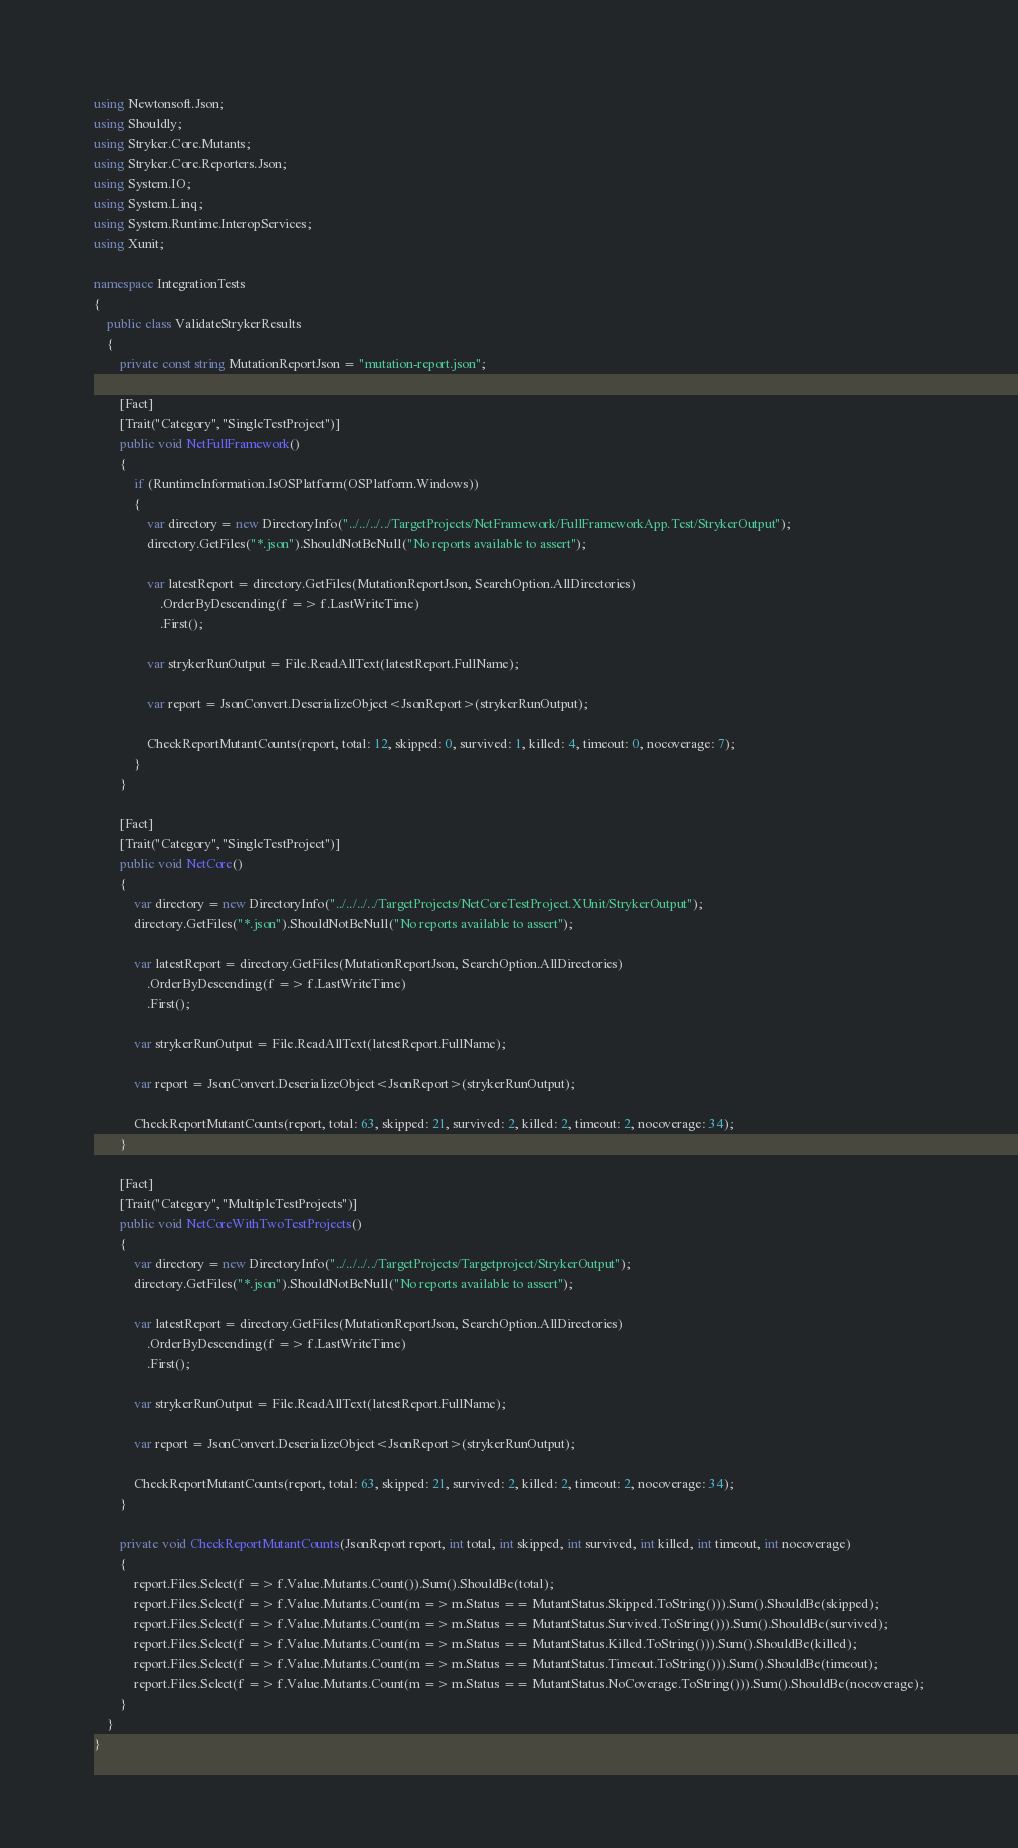Convert code to text. <code><loc_0><loc_0><loc_500><loc_500><_C#_>using Newtonsoft.Json;
using Shouldly;
using Stryker.Core.Mutants;
using Stryker.Core.Reporters.Json;
using System.IO;
using System.Linq;
using System.Runtime.InteropServices;
using Xunit;

namespace IntegrationTests
{
    public class ValidateStrykerResults
    {
        private const string MutationReportJson = "mutation-report.json";

        [Fact]
        [Trait("Category", "SingleTestProject")]
        public void NetFullFramework()
        {
            if (RuntimeInformation.IsOSPlatform(OSPlatform.Windows))
            {
                var directory = new DirectoryInfo("../../../../TargetProjects/NetFramework/FullFrameworkApp.Test/StrykerOutput");
                directory.GetFiles("*.json").ShouldNotBeNull("No reports available to assert");

                var latestReport = directory.GetFiles(MutationReportJson, SearchOption.AllDirectories)
                    .OrderByDescending(f => f.LastWriteTime)
                    .First();

                var strykerRunOutput = File.ReadAllText(latestReport.FullName);

                var report = JsonConvert.DeserializeObject<JsonReport>(strykerRunOutput);

                CheckReportMutantCounts(report, total: 12, skipped: 0, survived: 1, killed: 4, timeout: 0, nocoverage: 7);
            }
        }

        [Fact]
        [Trait("Category", "SingleTestProject")]
        public void NetCore()
        {
            var directory = new DirectoryInfo("../../../../TargetProjects/NetCoreTestProject.XUnit/StrykerOutput");
            directory.GetFiles("*.json").ShouldNotBeNull("No reports available to assert");

            var latestReport = directory.GetFiles(MutationReportJson, SearchOption.AllDirectories)
                .OrderByDescending(f => f.LastWriteTime)
                .First();

            var strykerRunOutput = File.ReadAllText(latestReport.FullName);

            var report = JsonConvert.DeserializeObject<JsonReport>(strykerRunOutput);

            CheckReportMutantCounts(report, total: 63, skipped: 21, survived: 2, killed: 2, timeout: 2, nocoverage: 34);
        }

        [Fact]
        [Trait("Category", "MultipleTestProjects")]
        public void NetCoreWithTwoTestProjects()
        {
            var directory = new DirectoryInfo("../../../../TargetProjects/Targetproject/StrykerOutput");
            directory.GetFiles("*.json").ShouldNotBeNull("No reports available to assert");

            var latestReport = directory.GetFiles(MutationReportJson, SearchOption.AllDirectories)
                .OrderByDescending(f => f.LastWriteTime)
                .First();

            var strykerRunOutput = File.ReadAllText(latestReport.FullName);

            var report = JsonConvert.DeserializeObject<JsonReport>(strykerRunOutput);

            CheckReportMutantCounts(report, total: 63, skipped: 21, survived: 2, killed: 2, timeout: 2, nocoverage: 34);
        }

        private void CheckReportMutantCounts(JsonReport report, int total, int skipped, int survived, int killed, int timeout, int nocoverage)
        {
            report.Files.Select(f => f.Value.Mutants.Count()).Sum().ShouldBe(total);
            report.Files.Select(f => f.Value.Mutants.Count(m => m.Status == MutantStatus.Skipped.ToString())).Sum().ShouldBe(skipped);
            report.Files.Select(f => f.Value.Mutants.Count(m => m.Status == MutantStatus.Survived.ToString())).Sum().ShouldBe(survived);
            report.Files.Select(f => f.Value.Mutants.Count(m => m.Status == MutantStatus.Killed.ToString())).Sum().ShouldBe(killed);
            report.Files.Select(f => f.Value.Mutants.Count(m => m.Status == MutantStatus.Timeout.ToString())).Sum().ShouldBe(timeout);
            report.Files.Select(f => f.Value.Mutants.Count(m => m.Status == MutantStatus.NoCoverage.ToString())).Sum().ShouldBe(nocoverage);
        }
    }
}
</code> 